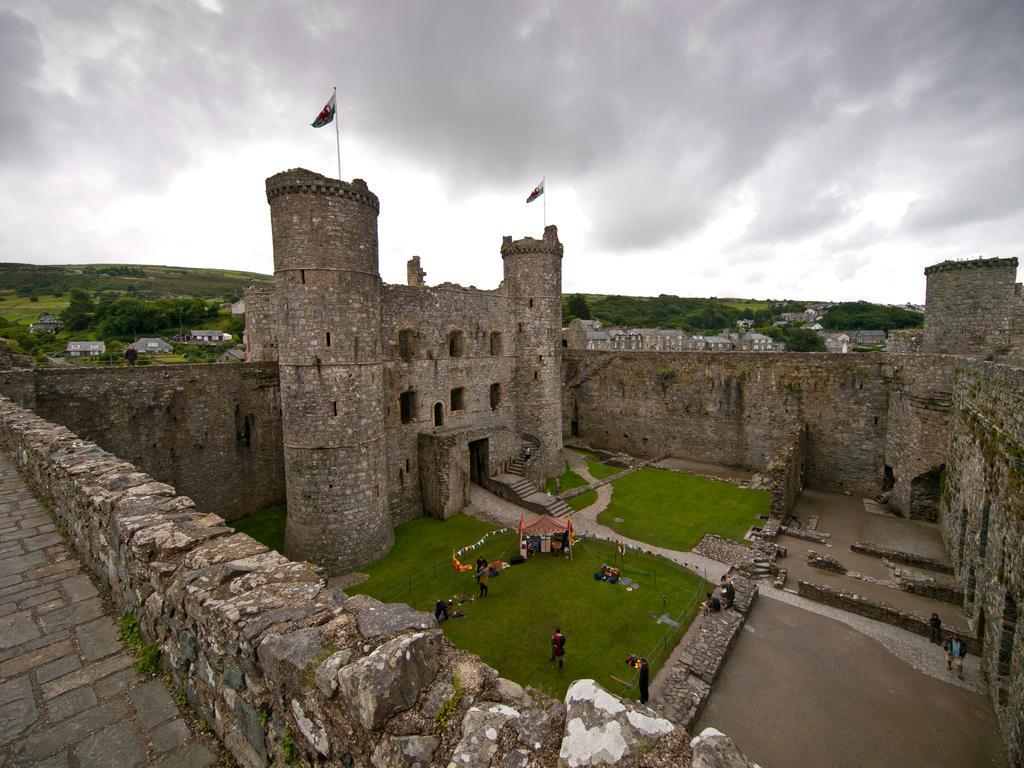Please provide a concise description of this image. In this image there is a fort, group of people standing , a stall, flags with the poles, and in the background there are buildings, trees, hills,sky. 